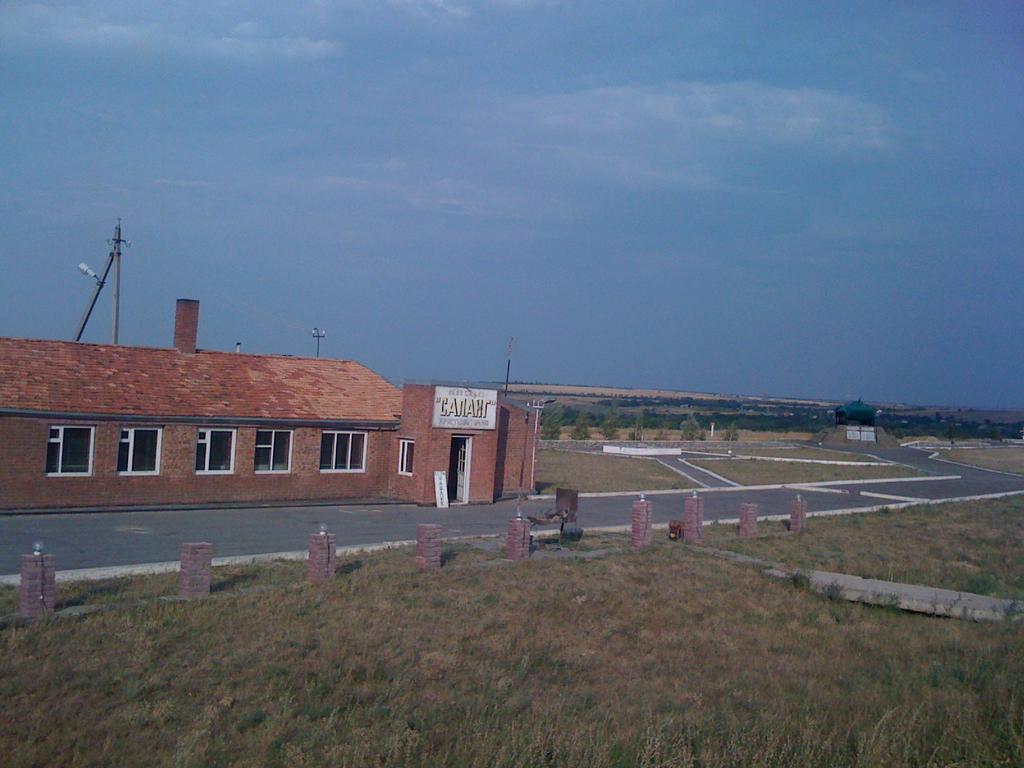In one or two sentences, can you explain what this image depicts? In this image we can see the building, in front of the building we can see the road, gate, ground and pillars with lights. And there are street lights, trees and the sky. 